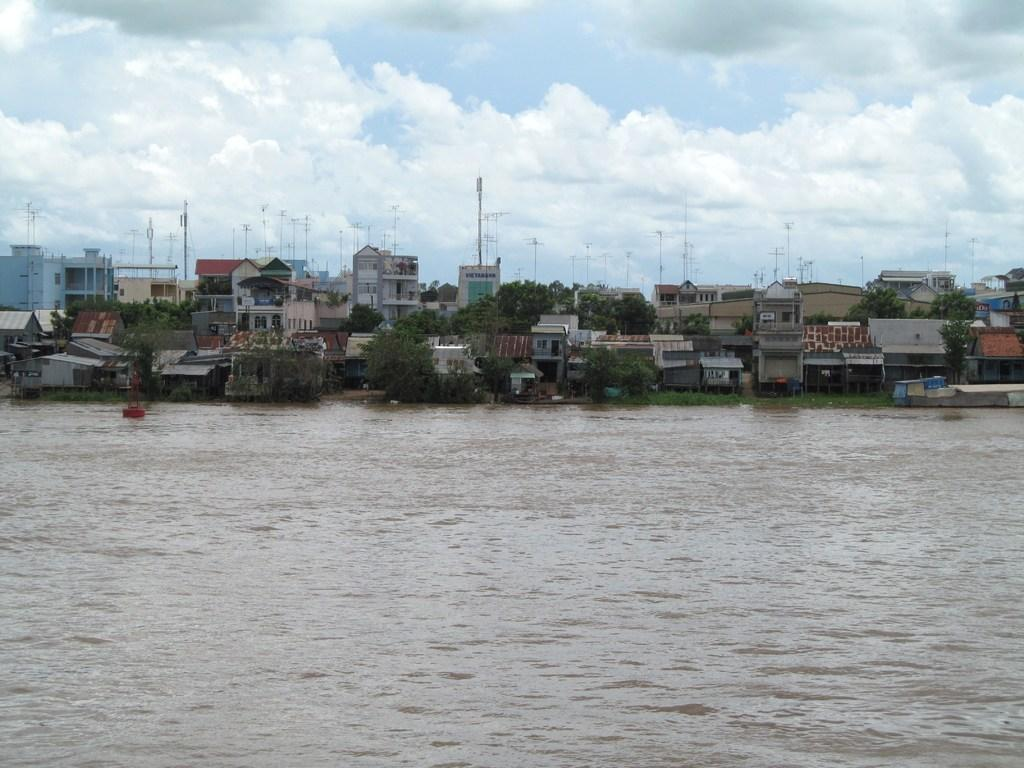What type of natural feature is present in the image? There is a river in the image. What type of man-made structures can be seen in the image? There are buildings visible in the image. What type of vegetation is present in the image? There are trees in the image. What type of vertical structures are present in the image? There are poles in the image. What is visible in the background of the image? The sky is visible in the background of the image. What type of sidewalk can be seen near the river in the image? There is no sidewalk present in the image; it features a river, buildings, trees, poles, and the sky. What type of class is being taught near the river in the image? There is no class or teaching activity present in the image; it features a river, buildings, trees, poles, and the sky. 